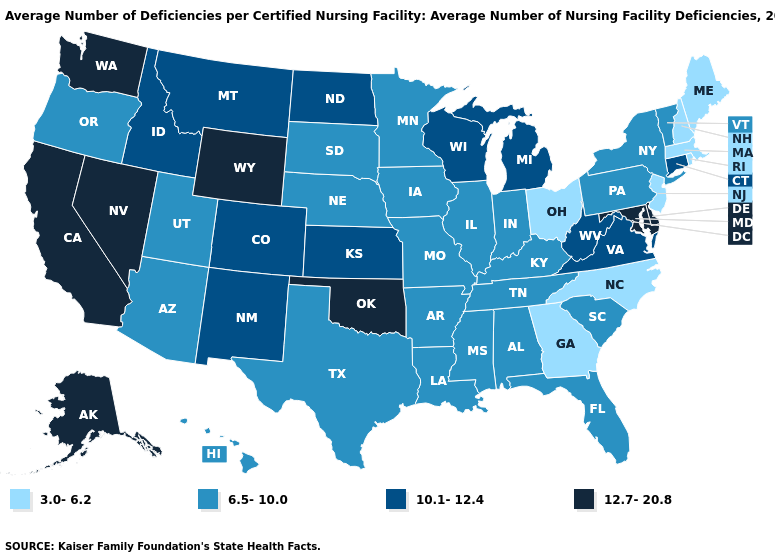Name the states that have a value in the range 10.1-12.4?
Short answer required. Colorado, Connecticut, Idaho, Kansas, Michigan, Montana, New Mexico, North Dakota, Virginia, West Virginia, Wisconsin. Name the states that have a value in the range 3.0-6.2?
Be succinct. Georgia, Maine, Massachusetts, New Hampshire, New Jersey, North Carolina, Ohio, Rhode Island. Is the legend a continuous bar?
Be succinct. No. Does Wyoming have the lowest value in the USA?
Quick response, please. No. What is the value of South Carolina?
Be succinct. 6.5-10.0. Does Massachusetts have the lowest value in the USA?
Write a very short answer. Yes. What is the value of New Jersey?
Quick response, please. 3.0-6.2. Name the states that have a value in the range 6.5-10.0?
Concise answer only. Alabama, Arizona, Arkansas, Florida, Hawaii, Illinois, Indiana, Iowa, Kentucky, Louisiana, Minnesota, Mississippi, Missouri, Nebraska, New York, Oregon, Pennsylvania, South Carolina, South Dakota, Tennessee, Texas, Utah, Vermont. Name the states that have a value in the range 6.5-10.0?
Write a very short answer. Alabama, Arizona, Arkansas, Florida, Hawaii, Illinois, Indiana, Iowa, Kentucky, Louisiana, Minnesota, Mississippi, Missouri, Nebraska, New York, Oregon, Pennsylvania, South Carolina, South Dakota, Tennessee, Texas, Utah, Vermont. Which states have the lowest value in the USA?
Keep it brief. Georgia, Maine, Massachusetts, New Hampshire, New Jersey, North Carolina, Ohio, Rhode Island. Among the states that border Maryland , which have the lowest value?
Quick response, please. Pennsylvania. What is the value of Tennessee?
Be succinct. 6.5-10.0. What is the value of Iowa?
Be succinct. 6.5-10.0. Does the first symbol in the legend represent the smallest category?
Short answer required. Yes. 